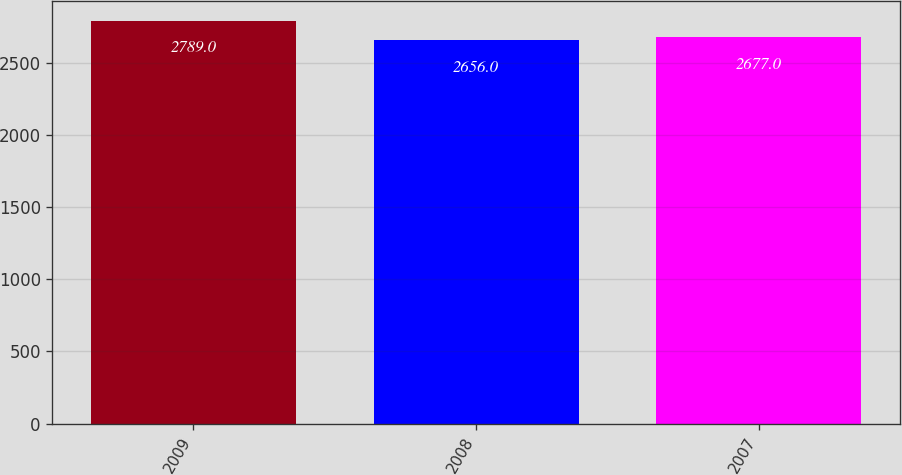Convert chart to OTSL. <chart><loc_0><loc_0><loc_500><loc_500><bar_chart><fcel>2009<fcel>2008<fcel>2007<nl><fcel>2789<fcel>2656<fcel>2677<nl></chart> 